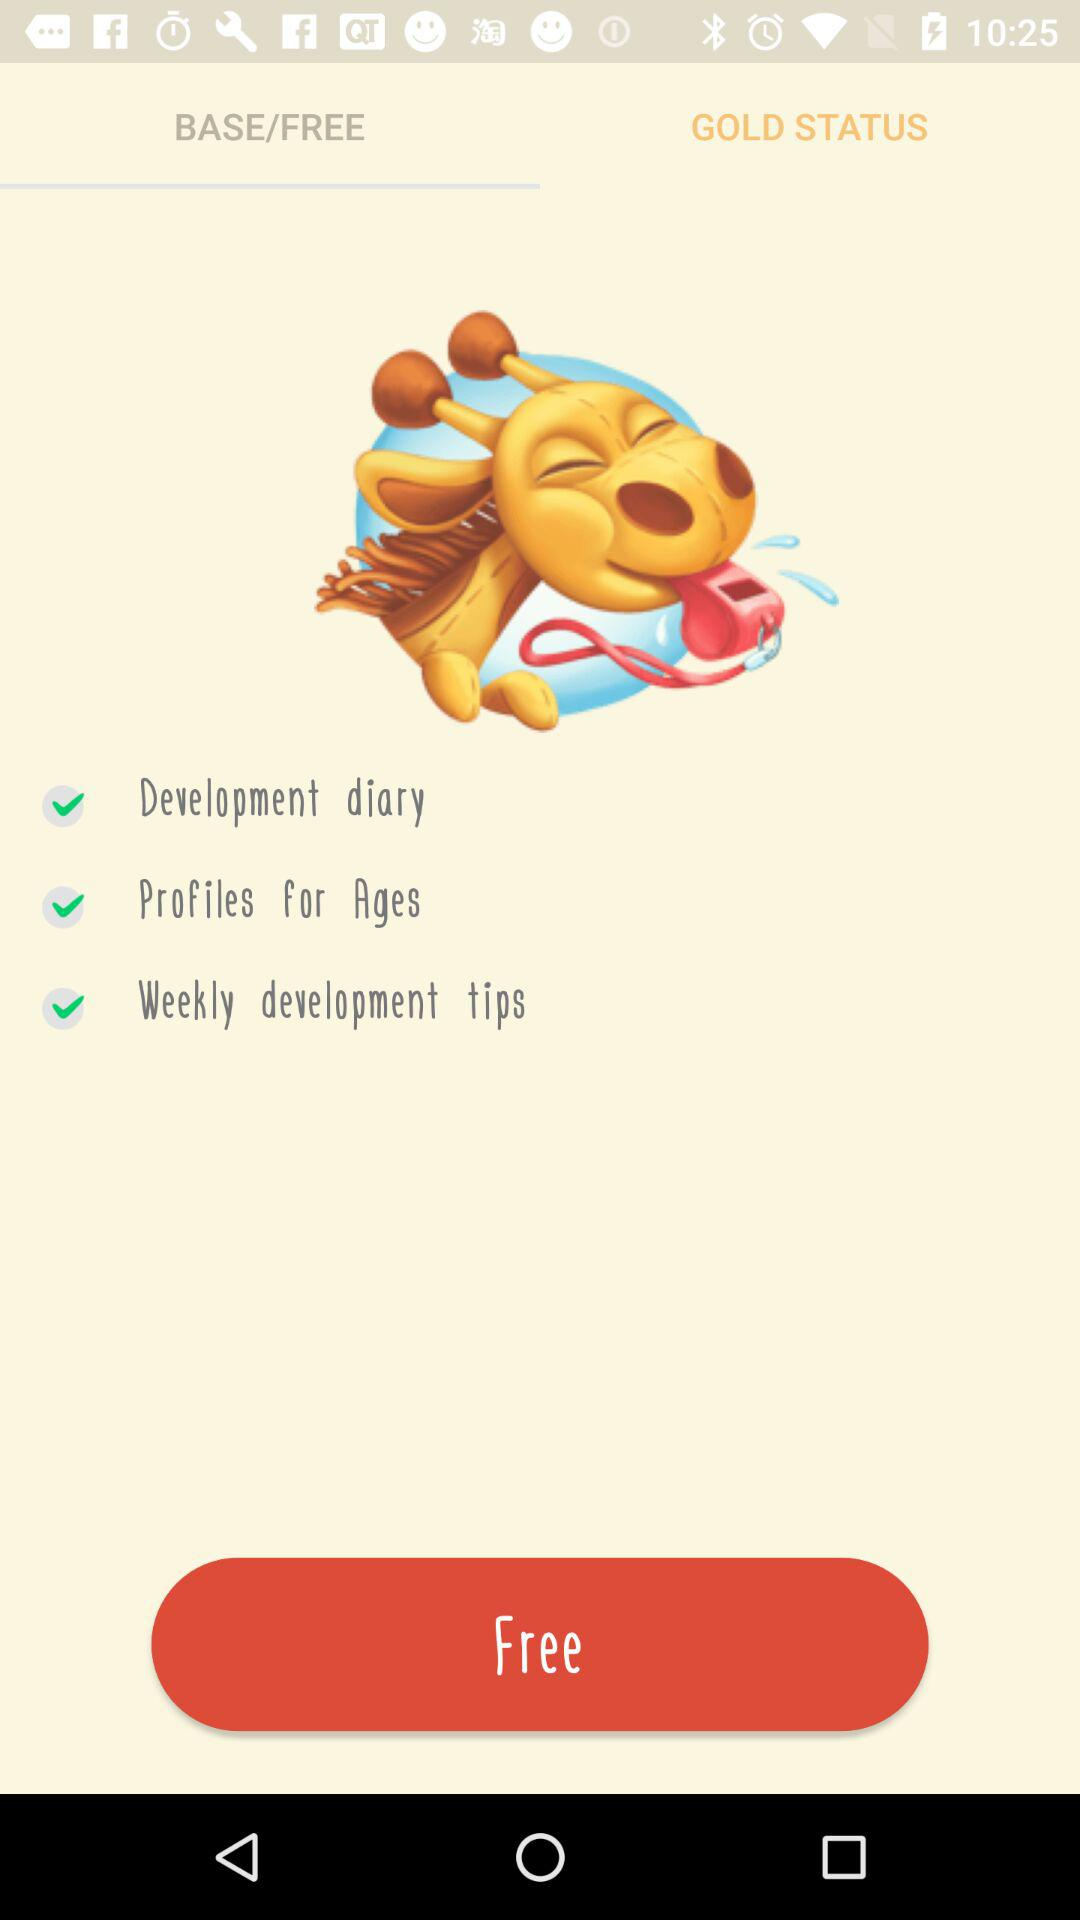What's the type of diary? The type of diary is "Development diary". 